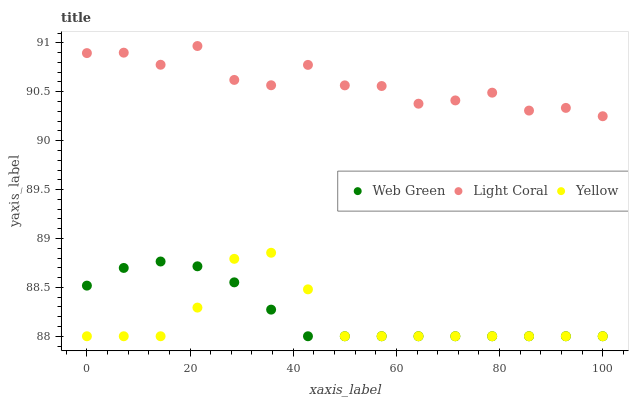Does Yellow have the minimum area under the curve?
Answer yes or no. Yes. Does Light Coral have the maximum area under the curve?
Answer yes or no. Yes. Does Web Green have the minimum area under the curve?
Answer yes or no. No. Does Web Green have the maximum area under the curve?
Answer yes or no. No. Is Web Green the smoothest?
Answer yes or no. Yes. Is Light Coral the roughest?
Answer yes or no. Yes. Is Yellow the smoothest?
Answer yes or no. No. Is Yellow the roughest?
Answer yes or no. No. Does Yellow have the lowest value?
Answer yes or no. Yes. Does Light Coral have the highest value?
Answer yes or no. Yes. Does Yellow have the highest value?
Answer yes or no. No. Is Yellow less than Light Coral?
Answer yes or no. Yes. Is Light Coral greater than Web Green?
Answer yes or no. Yes. Does Web Green intersect Yellow?
Answer yes or no. Yes. Is Web Green less than Yellow?
Answer yes or no. No. Is Web Green greater than Yellow?
Answer yes or no. No. Does Yellow intersect Light Coral?
Answer yes or no. No. 